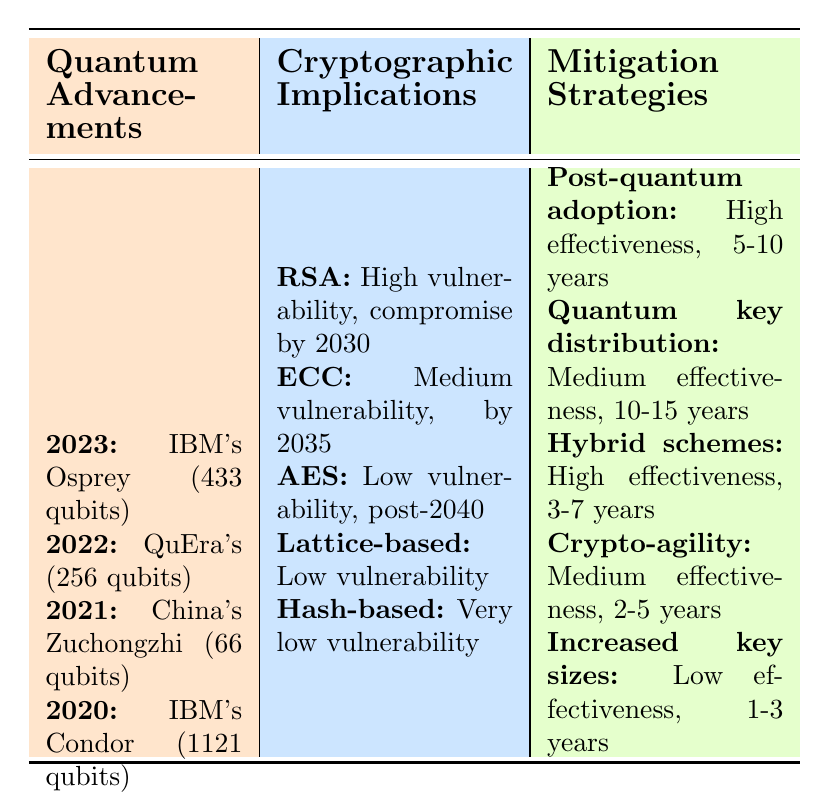What achievement did Google's Sycamore processor make in 2019? In the table under the "Quantum Advancements" section, it states that Google's Sycamore processor achieved quantum supremacy in 2019.
Answer: Achieved quantum supremacy What is the quantum vulnerability of RSA? Referring to the "Cryptographic Implications" section, RSA has a high quantum vulnerability.
Answer: High Which quantum computer was associated with a potential threat to elliptic curve cryptography? In the table, it indicates that IBM's Quantum Condor processor, developed in 2020, threatens elliptic curve cryptography.
Answer: IBM's Quantum Condor processor By when is RSA expected to be compromised? According to the "Cryptographic Implications" section, RSA is expected to be compromised by 2030.
Answer: By 2030 What is the estimated compromise time for elliptic curve cryptography? Looking at the "Cryptographic Implications" section, it is mentioned that the estimated compromise time for elliptic curve cryptography is by 2035.
Answer: By 2035 Are hybrid classical-quantum schemes easy to implement? The table states that hybrid classical-quantum schemes have a medium implementation difficulty, which implies they are not the easiest to implement.
Answer: No Which quantum advancement has the highest number of qubits according to the table? It mentions that IBM's Quantum Condor processor has 1121 qubits, which is the highest among the listed advancements.
Answer: IBM's Quantum Condor processor What is the effectiveness rating of post-quantum cryptography adoption? From the "Mitigation Strategies" section, post-quantum cryptography adoption has a high effectiveness rating.
Answer: High Which algorithm is identified with very low quantum vulnerability? The "Cryptographic Implications" section shows that hash-based signatures have a very low quantum vulnerability.
Answer: Hash-based signatures Summing the qubits of IBM's Quantum Osprey and QuEra's processors, what is the total number of qubits? The total number of qubits from IBM's Osprey (433 qubits) and QuEra's processor (256 qubits) is calculated by adding them together: 433 + 256 = 689.
Answer: 689 What is the timeline for implementation of quantum key distribution? The table shows that the timeline for implementing quantum key distribution is estimated to be 10-15 years.
Answer: 10-15 years Which mitigation strategy has the shortest timeline for implementation? Viewing the "Mitigation Strategies," increased key sizes for classical algorithms has a timeline of 1-3 years, which is the shortest.
Answer: Increased key sizes for classical algorithms What impact do the latest advancements in quantum computing have on the AES encryption standard? The table indicates that the latest advancement, IBM's Osprey, challenges the AES-256 encryption standard.
Answer: Challenges AES-256 Is it true that lattice-based cryptography is currently widely used? The table states that lattice-based cryptography is under development, so it is not widely used.
Answer: No What is the effectiveness of crypto-agility frameworks? According to the "Mitigation Strategies," crypto-agility frameworks have a medium effectiveness.
Answer: Medium 